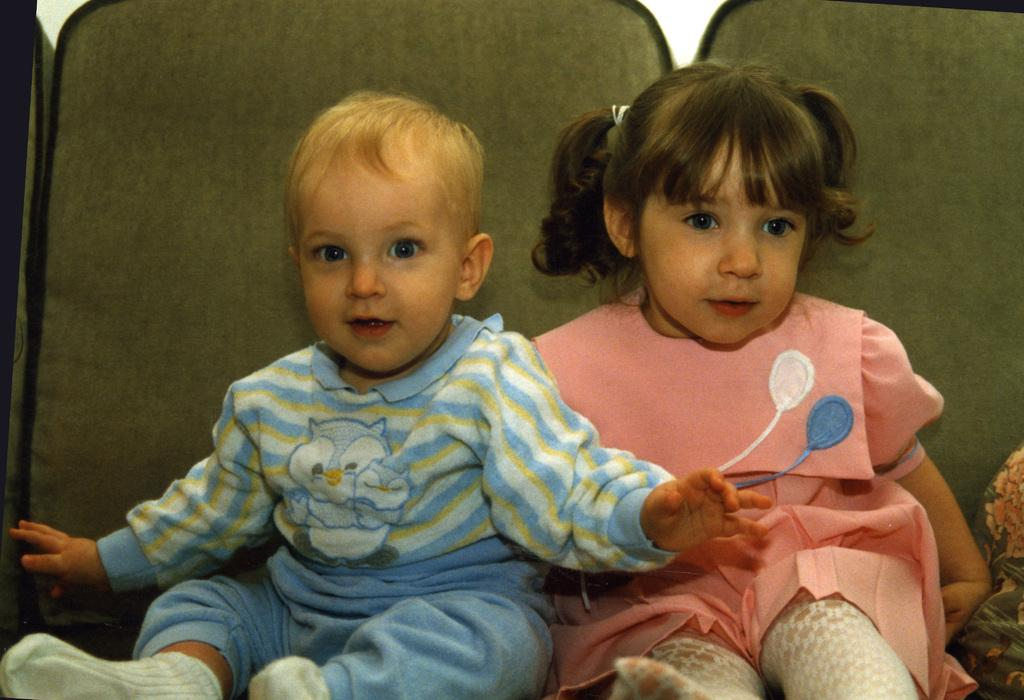How many children are in the image? There are two children in the image. What are the children doing in the image? The children are sitting on chairs. What color are the chairs the children are sitting on? The chairs are green in color. What is the color of the background in the image? The background of the image is white. Can you see a hole in the image? There is no hole present in the image. 